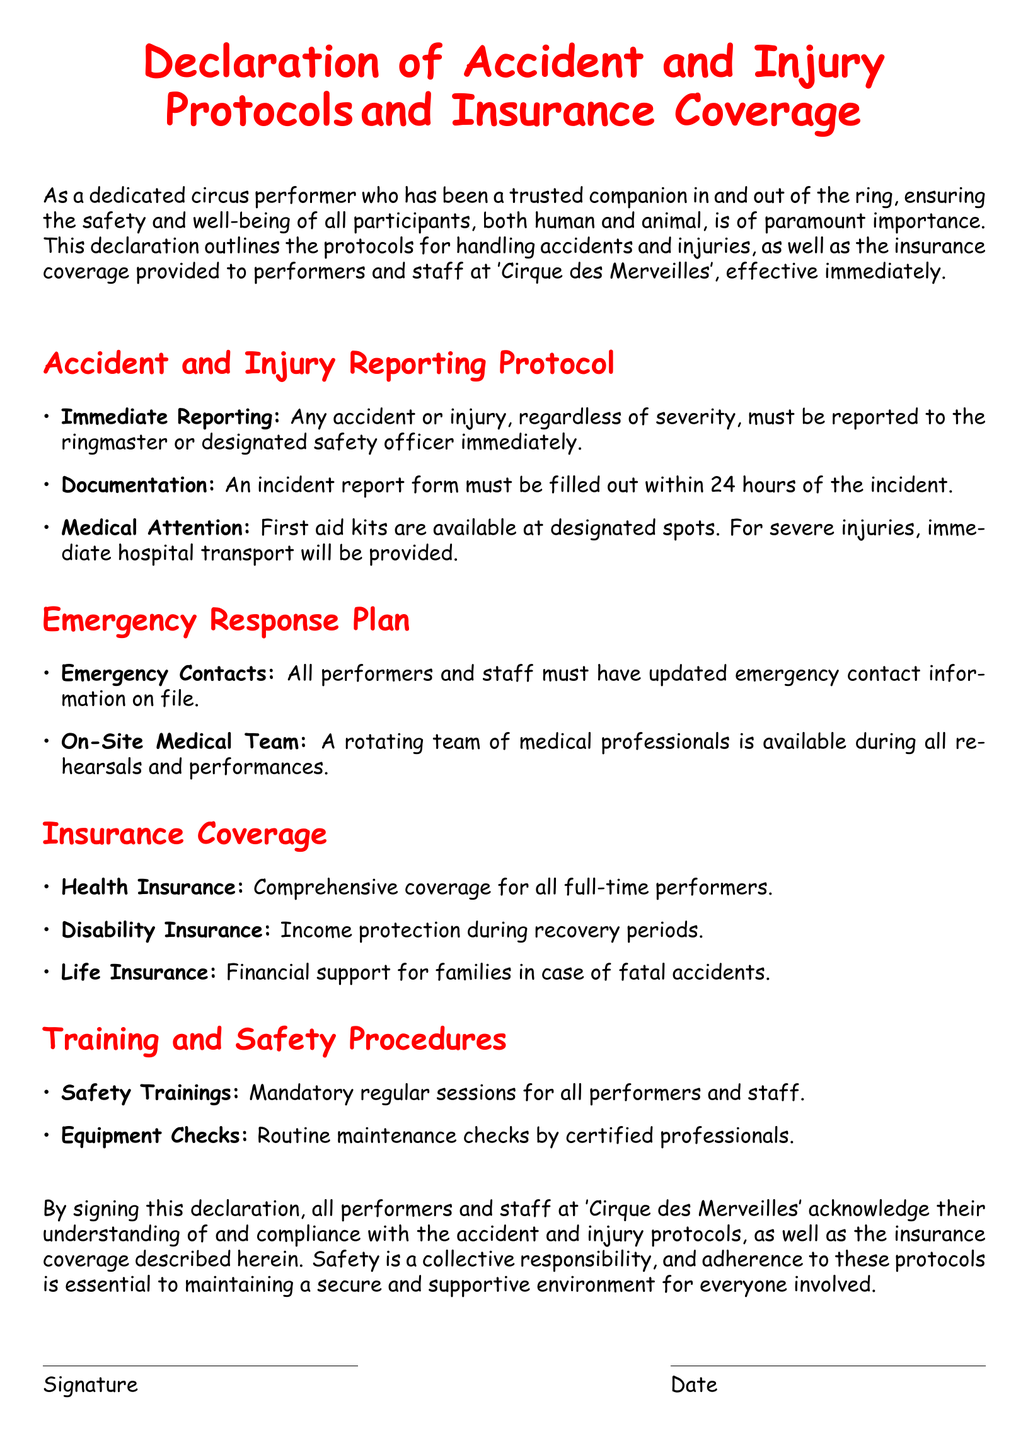What is the title of the document? The title of the document is clearly stated at the beginning, which is "Declaration of Accident and Injury Protocols and Insurance Coverage."
Answer: Declaration of Accident and Injury Protocols and Insurance Coverage Who must accidents be reported to? The document specifies that accidents must be reported to the ringmaster or designated safety officer.
Answer: ringmaster or designated safety officer What is required within 24 hours of an incident? The document indicates that an incident report form must be filled out within 24 hours of the incident.
Answer: incident report form What type of insurance is provided for income protection? The document mentions disability insurance specifically for income protection during recovery periods.
Answer: Disability Insurance How many types of insurance are listed in the document? The document outlines three types of insurance coverage: health, disability, and life insurance.
Answer: Three What is the primary responsibility outlined in the declaration? The declaration emphasizes that safety is a collective responsibility for all participants involved.
Answer: collective responsibility Who is responsible for conducting routine equipment checks? The document states that routine maintenance checks are performed by certified professionals.
Answer: certified professionals What must all performers and staff have updated? The document indicates that all performers and staff must have updated emergency contact information on file.
Answer: emergency contact information What is the purpose of the signed declaration? The signed declaration acknowledges the understanding and compliance with the accident and injury protocols and insurance coverage described.
Answer: understanding and compliance 